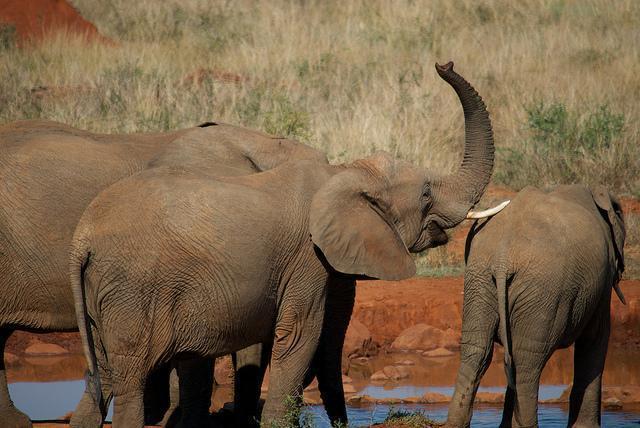How many elephants are in the picture?
Give a very brief answer. 3. How many elephants are there?
Give a very brief answer. 3. How many elephants are visible?
Give a very brief answer. 3. 